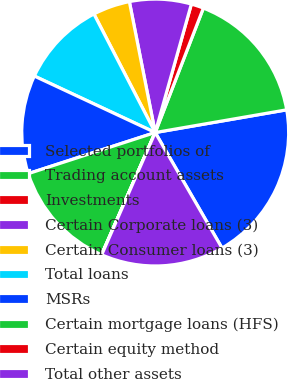<chart> <loc_0><loc_0><loc_500><loc_500><pie_chart><fcel>Selected portfolios of<fcel>Trading account assets<fcel>Investments<fcel>Certain Corporate loans (3)<fcel>Certain Consumer loans (3)<fcel>Total loans<fcel>MSRs<fcel>Certain mortgage loans (HFS)<fcel>Certain equity method<fcel>Total other assets<nl><fcel>19.38%<fcel>16.4%<fcel>1.51%<fcel>7.47%<fcel>4.49%<fcel>10.45%<fcel>11.94%<fcel>13.43%<fcel>0.02%<fcel>14.91%<nl></chart> 